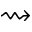<formula> <loc_0><loc_0><loc_500><loc_500>\right s q u i g a r r o w</formula> 